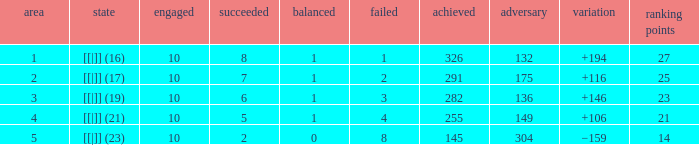 How many table points are listed for the deficit is +194?  1.0. 